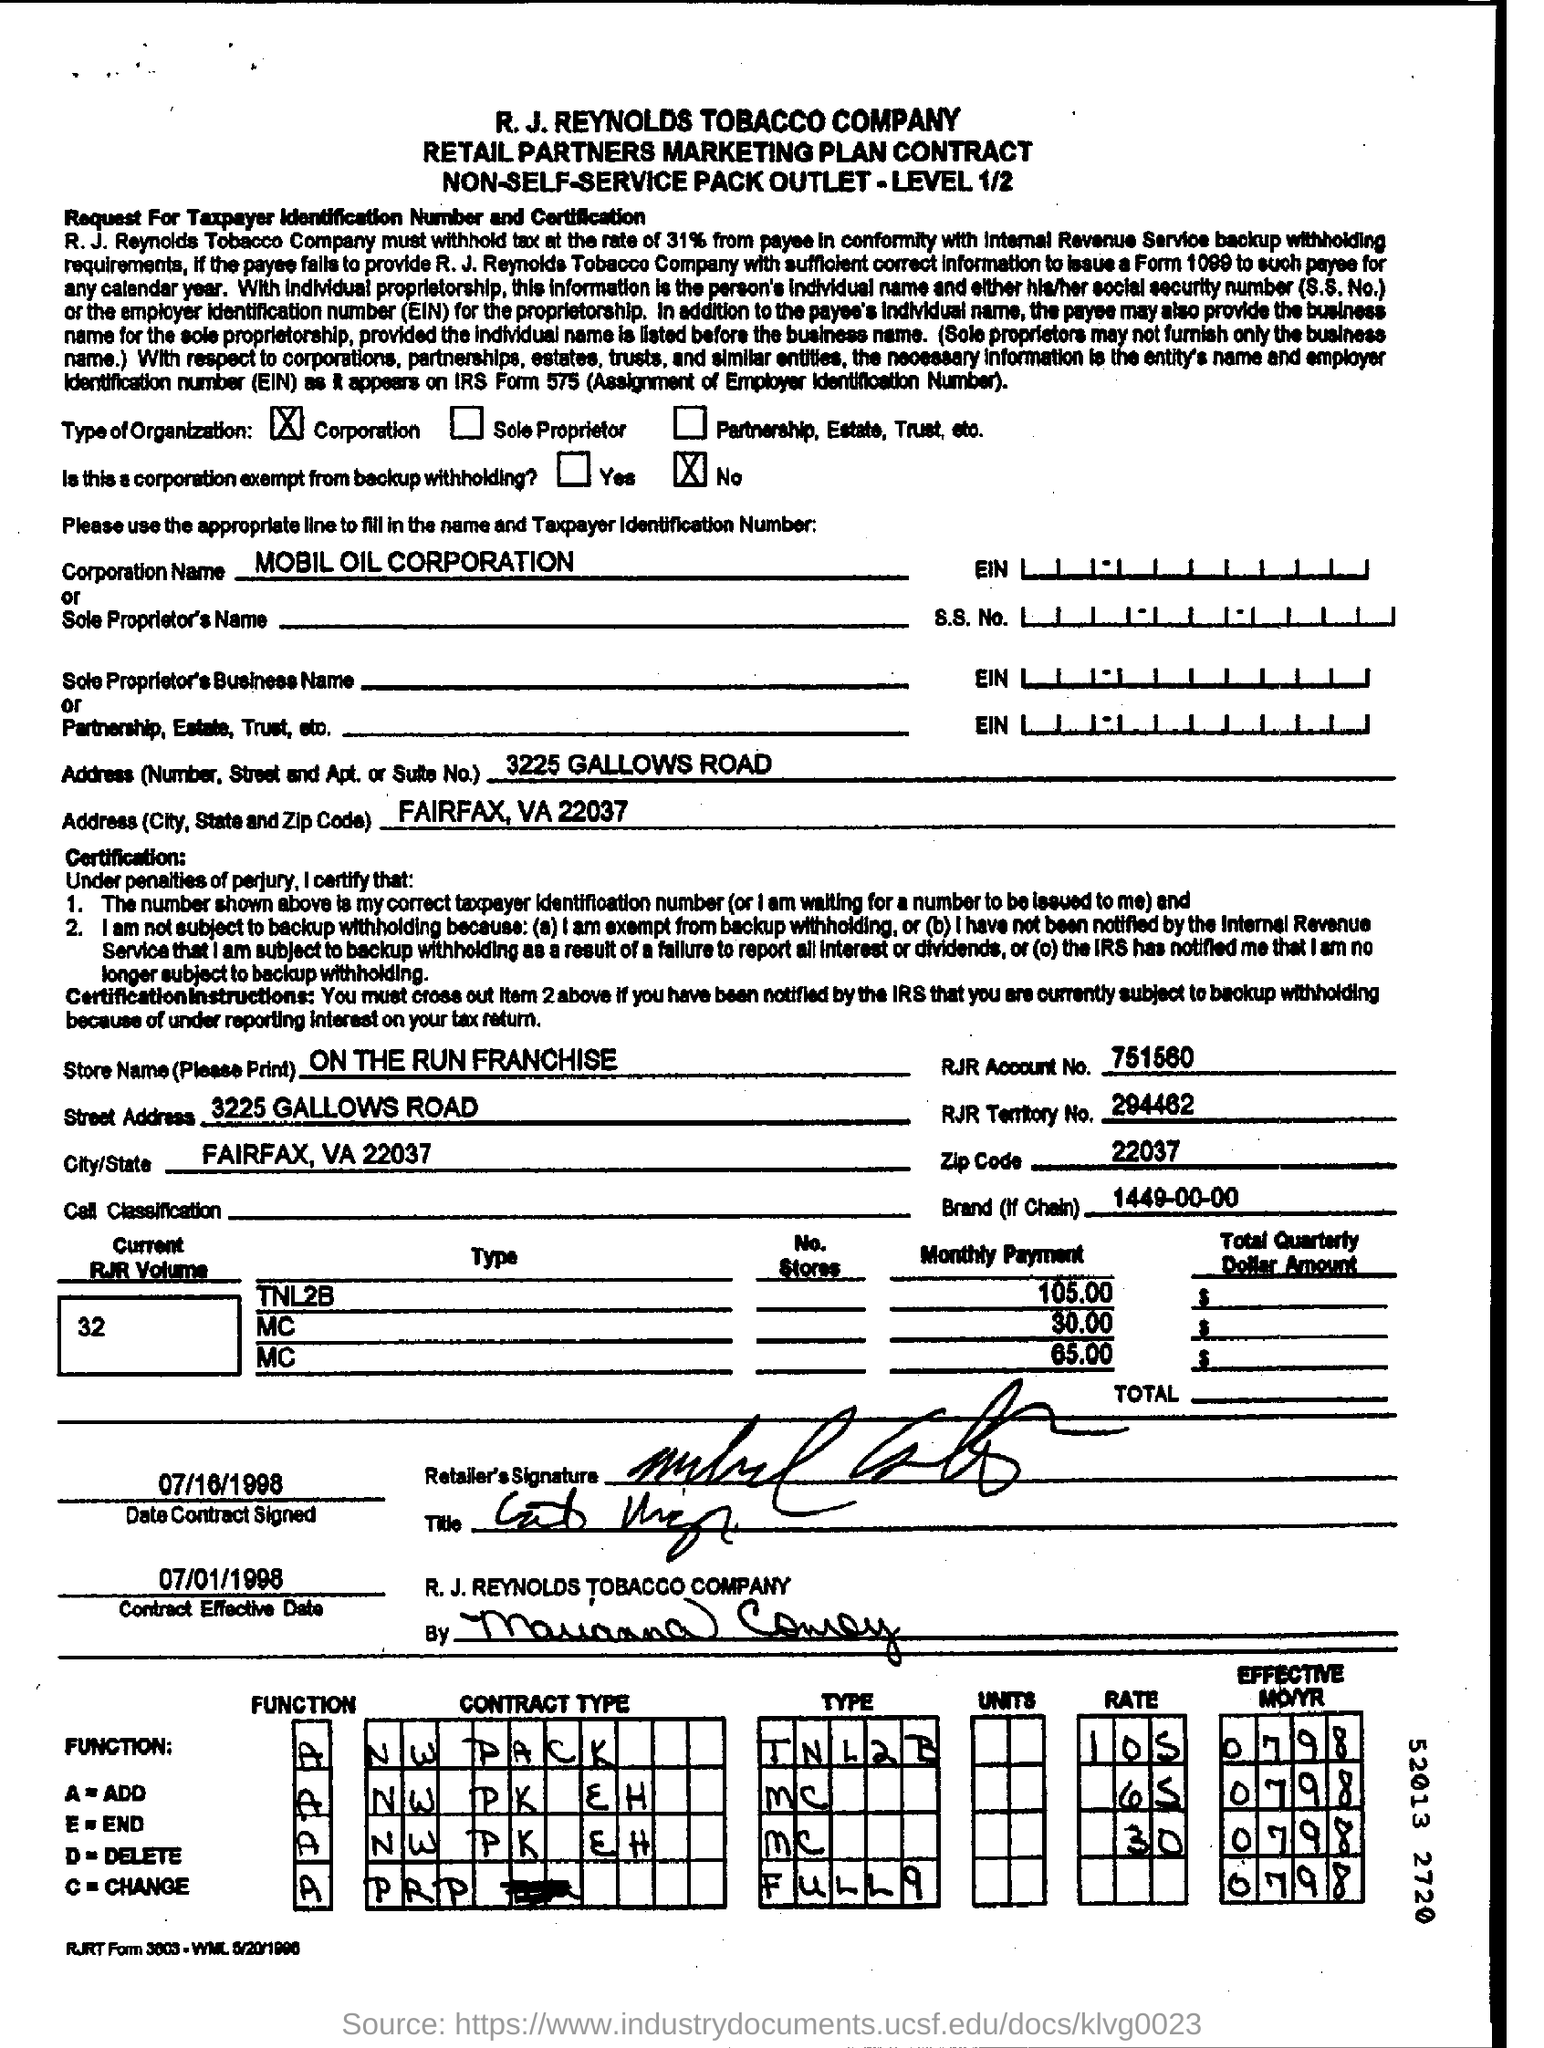What is the Corporation Name ?
Your response must be concise. MOBIL OIL  CORPORATION. What is the Zip Code Number ?
Your response must be concise. 22037. What is the Store Name ?
Offer a very short reply. ON THE RUN FRANCHISE. What is the Contract Effective Date ?
Give a very brief answer. 07/01/1998. What is written in the Brand Field ?
Your answer should be compact. 1449-00-00. 